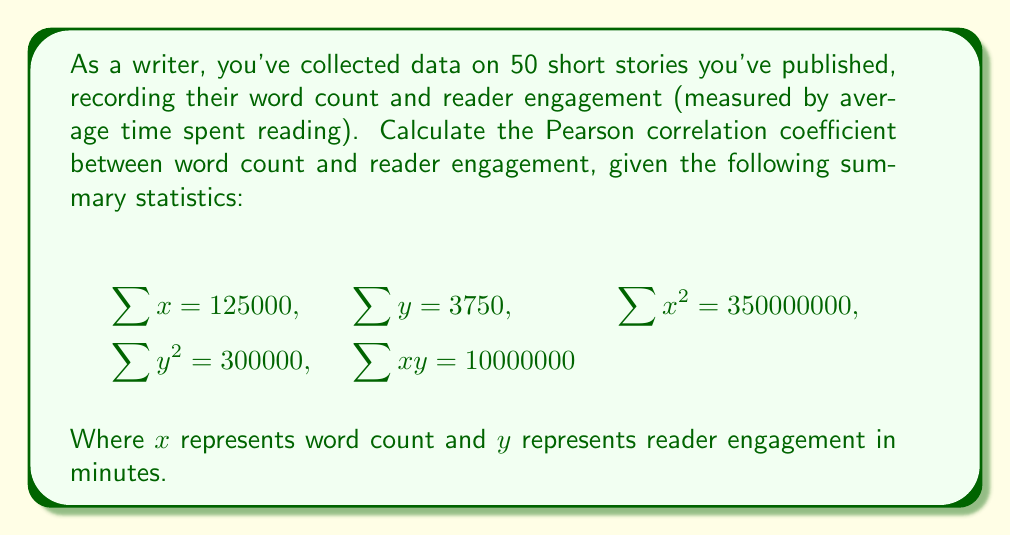Solve this math problem. To calculate the Pearson correlation coefficient (r), we'll use the formula:

$$r = \frac{n\sum xy - \sum x \sum y}{\sqrt{[n\sum x^2 - (\sum x)^2][n\sum y^2 - (\sum y)^2]}}$$

Where $n$ is the number of data points (50 in this case).

Step 1: Calculate the numerator
$n\sum xy - \sum x \sum y = 50(10000000) - 125000(3750) = 31250000$

Step 2: Calculate the first part of the denominator
$n\sum x^2 - (\sum x)^2 = 50(350000000) - (125000)^2 = 1562500000$

Step 3: Calculate the second part of the denominator
$n\sum y^2 - (\sum y)^2 = 50(300000) - (3750)^2 = 1406250$

Step 4: Multiply the results from steps 2 and 3
$1562500000 * 1406250 = 2.197265625 * 10^{15}$

Step 5: Take the square root of the result from step 4
$\sqrt{2.197265625 * 10^{15}} = 1482317.07$

Step 6: Divide the numerator by the denominator
$r = \frac{31250000}{1482317.07} = 0.2108$
Answer: $r = 0.2108$ 